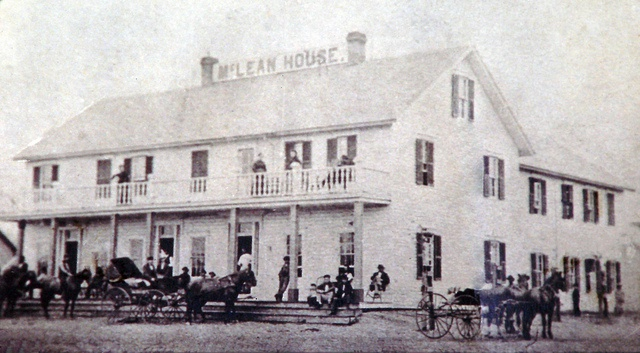Describe the objects in this image and their specific colors. I can see people in darkgray, black, gray, and lightgray tones, horse in darkgray, black, gray, and purple tones, horse in darkgray, black, gray, and purple tones, horse in darkgray, navy, black, and gray tones, and horse in darkgray, black, gray, and purple tones in this image. 